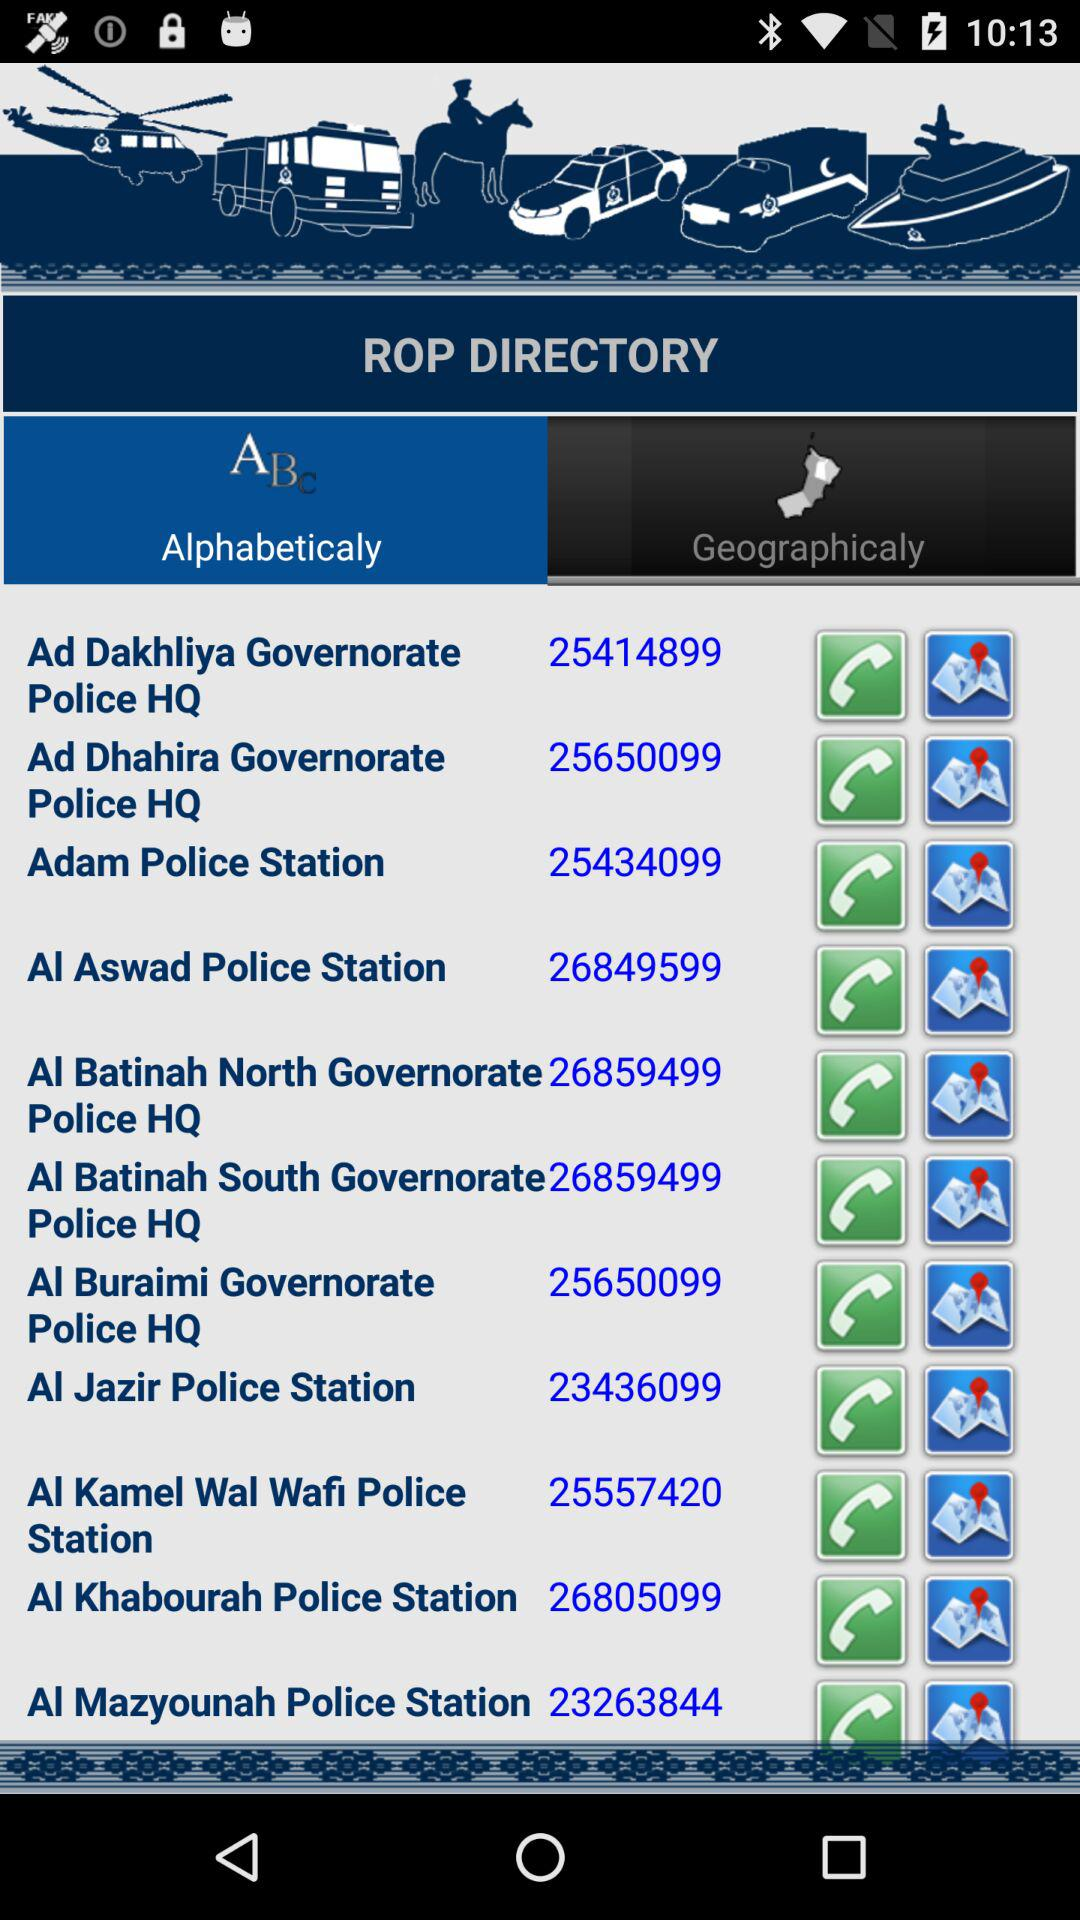Which tab is selected? The selected tab is "Alphabeticaly". 